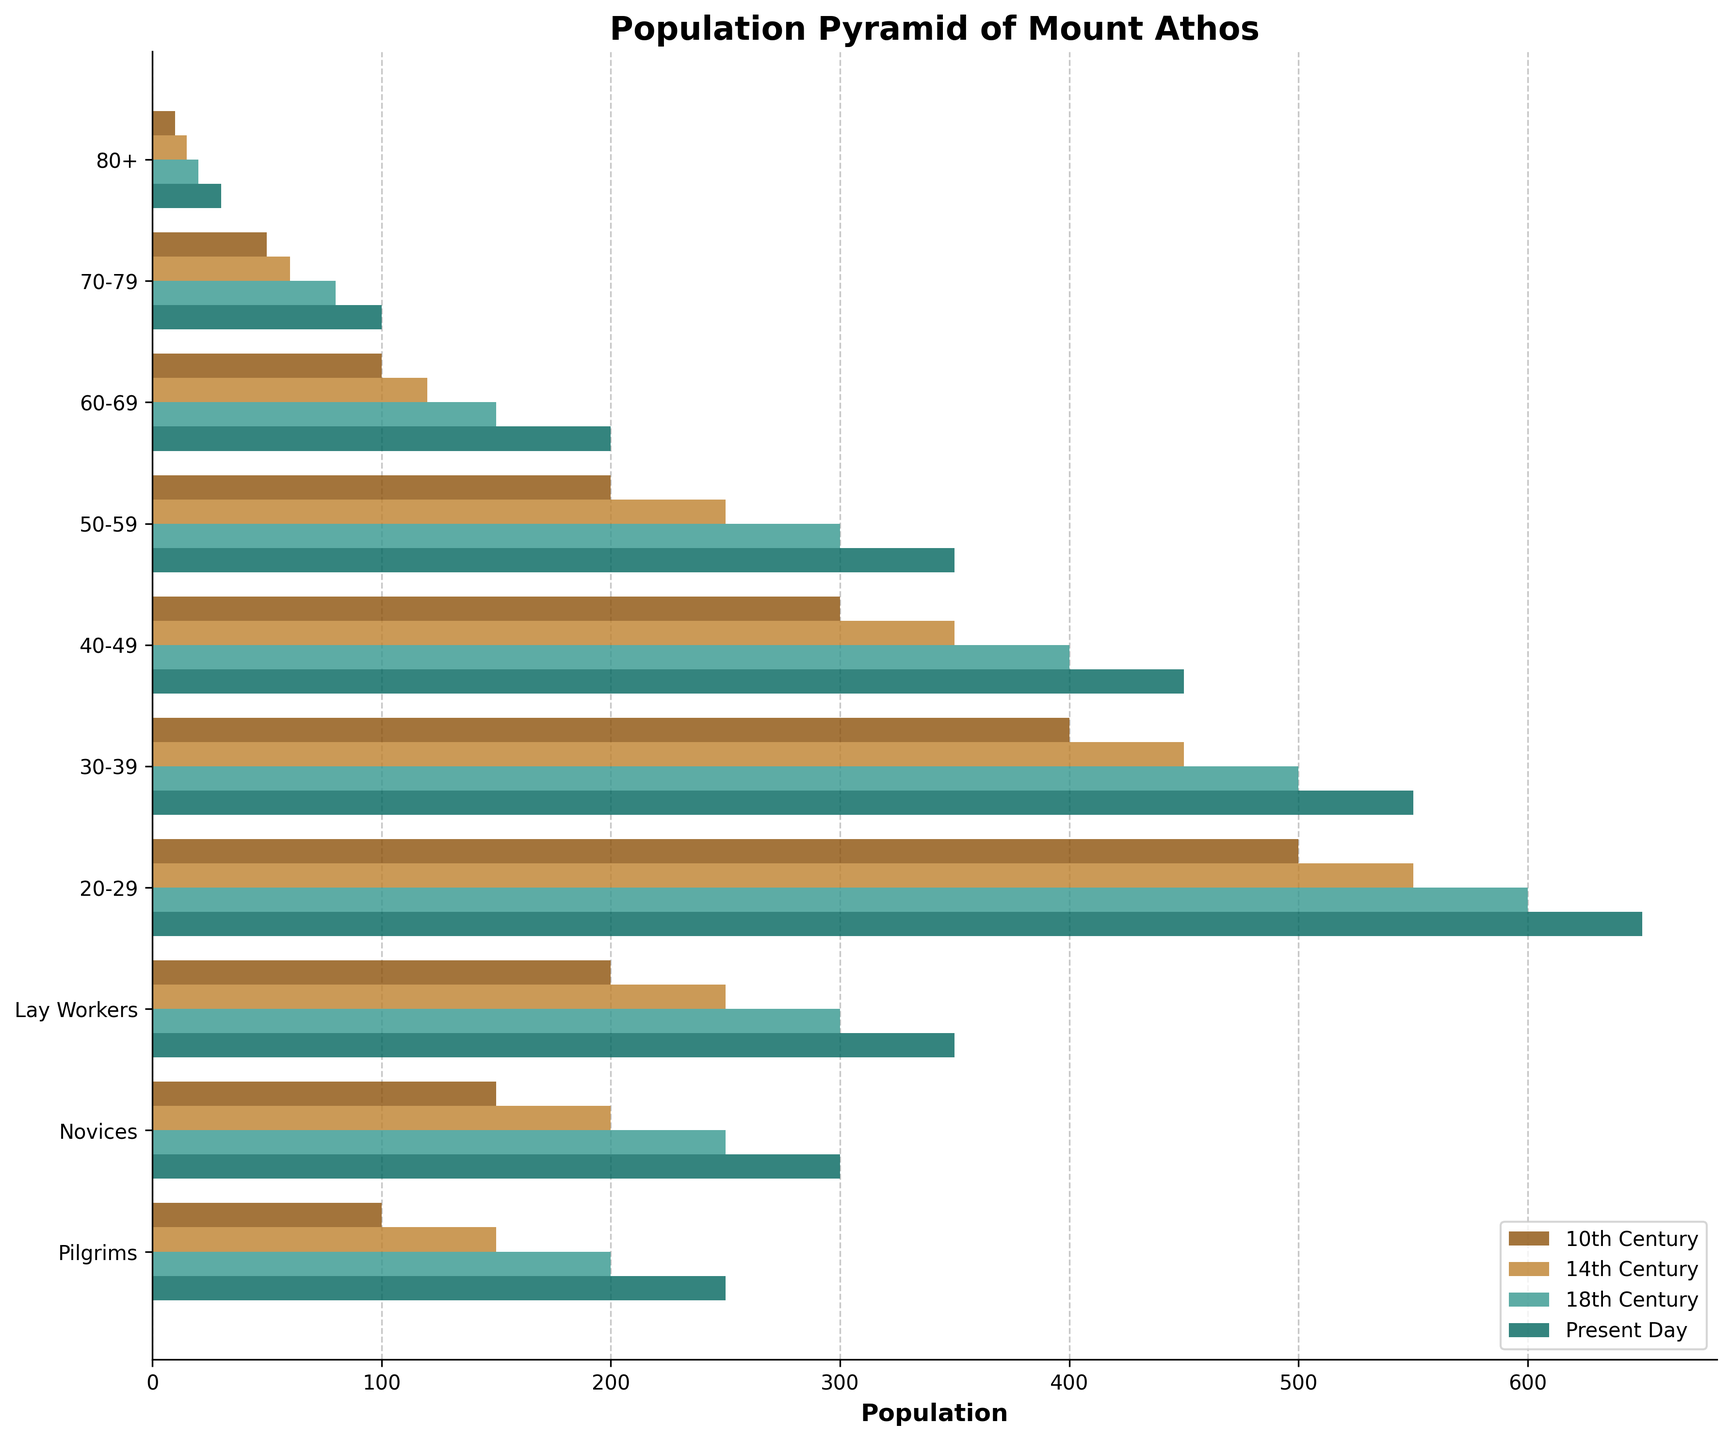What is the title of the figure? The title of the population pyramid is located at the top of the figure, and it says "Population Pyramid of Mount Athos."
Answer: Population Pyramid of Mount Athos What are the four centuries represented in each bar of the chart? The legend at the bottom right of the figure displays the four centuries represented, which are "10th Century," "14th Century," "18th Century," and "Present Day."
Answer: 10th Century, 14th Century, 18th Century, Present Day Which age group shows the highest population in the Present Day? In the Present Day category (green bars), the widest bar indicating the highest population is "20-29."
Answer: 20-29 How does the population of monks aged 30-39 in the 18th Century compare to that in the 14th Century? The bar for the 30-39 age group shows an increase from the 14th Century (orange bar) to the 18th Century (green bar), indicating that the population increased.
Answer: Increased What is the total population of the "50-59" age group across all centuries? The populations in the 50-59 age group for each century are 200, 250, 300, and 350. Adding them up gives a total of 1100.
Answer: 1100 Which age group has seen the smallest change in population from the 10th Century to Present Day? Comparing the changes for each age group, the "80+" age group shows the smallest change in population from 10 (10th Century) to 30 (Present Day), a change of 20.
Answer: 80+ Which category shows a consistent increase across all centuries? Observing the bars for each century, the "Novices" category shows a consistent increase from 150 (10th Century) to 300 (Present Day).
Answer: Novices Do lay workers have a higher population than pilgrims in the 14th Century? By comparing the bars in the 14th Century category, the population for "Lay Workers" is 250 while for "Pilgrims" it is 150, indicating that lay workers have a higher population.
Answer: Yes How many age groups were considered in the population pyramid? The y-axis lists the age groups represented in the figure, and there are eight age groups identified.
Answer: Eight What is the average population of monks in age group 20-29 across all centuries? The population numbers for the age group 20-29 are 500, 550, 600, and 650. Adding them and dividing by 4 gives an average of (500+550+600+650)/4 = 575.
Answer: 575 